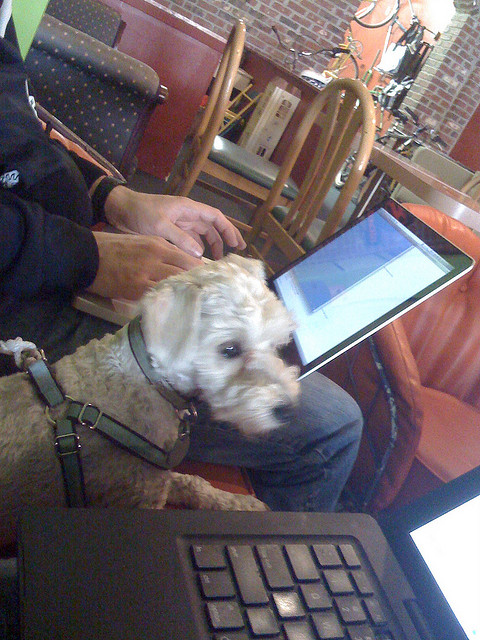<image>What is this dog looking at? It is unknown what the dog is looking at, it could be a laptop or a computer. What is this dog looking at? I don't know what this dog is looking at. It can be a computer, laptop, or laptop screen. 